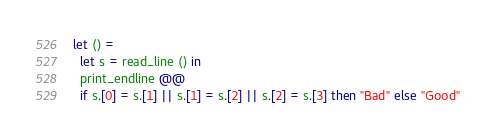Convert code to text. <code><loc_0><loc_0><loc_500><loc_500><_OCaml_>let () =
  let s = read_line () in
  print_endline @@
  if s.[0] = s.[1] || s.[1] = s.[2] || s.[2] = s.[3] then "Bad" else "Good"
</code> 